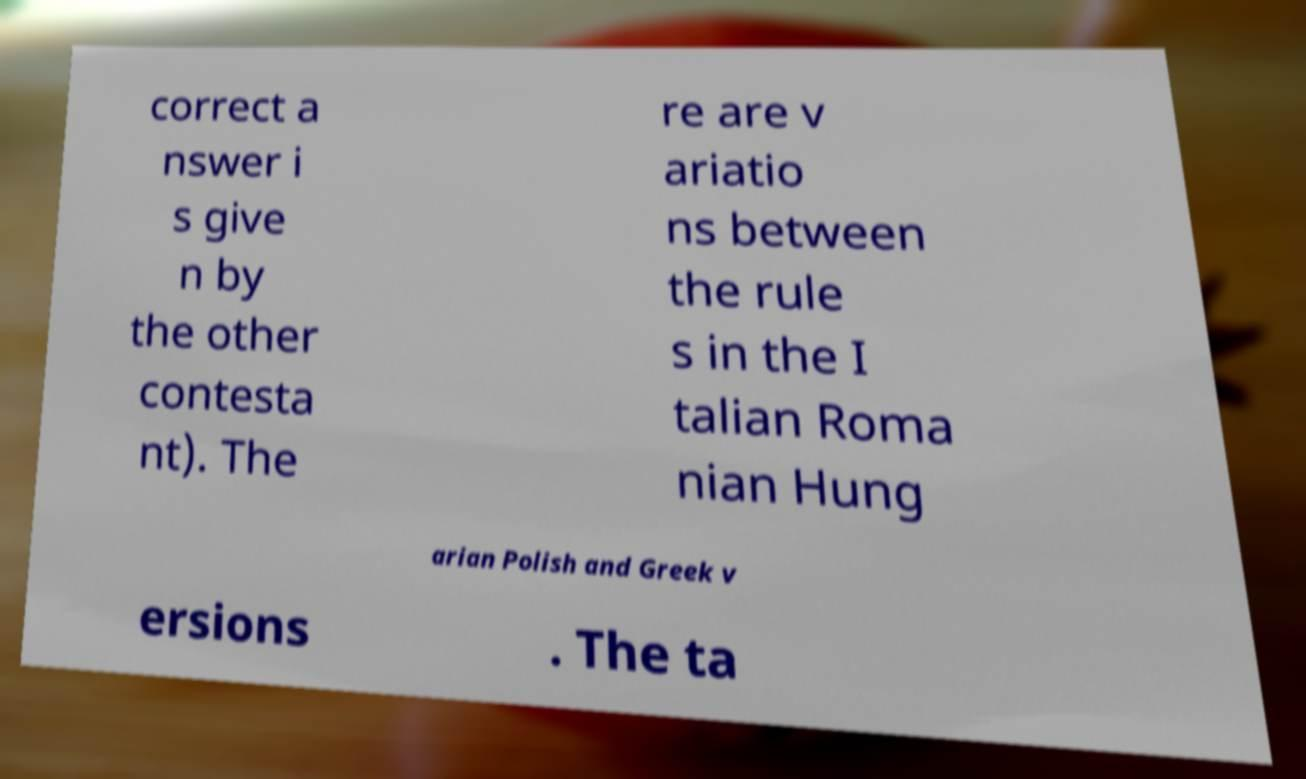Can you accurately transcribe the text from the provided image for me? correct a nswer i s give n by the other contesta nt). The re are v ariatio ns between the rule s in the I talian Roma nian Hung arian Polish and Greek v ersions . The ta 